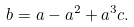Convert formula to latex. <formula><loc_0><loc_0><loc_500><loc_500>b = a - a ^ { 2 } + a ^ { 3 } c .</formula> 